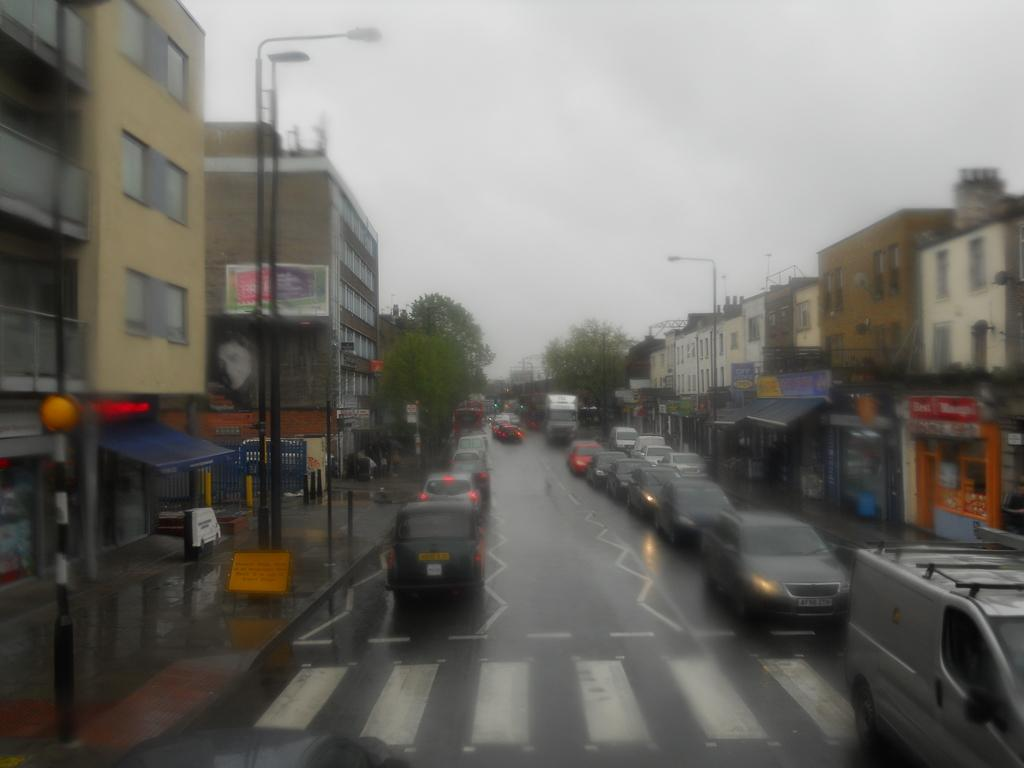What is happening on the road in the image? There are vehicles moving on the road in the image. What can be seen near the road? Buildings, trees, shops, and sign boards are visible near the road. Can you describe the surroundings of the road? The road is surrounded by buildings, trees, and shops, with sign boards providing information or directions. How many geese are crossing the road in the image? There are no geese present in the image; it only shows vehicles moving on the road. What type of kettle can be seen boiling water in the image? There is no kettle present in the image. 